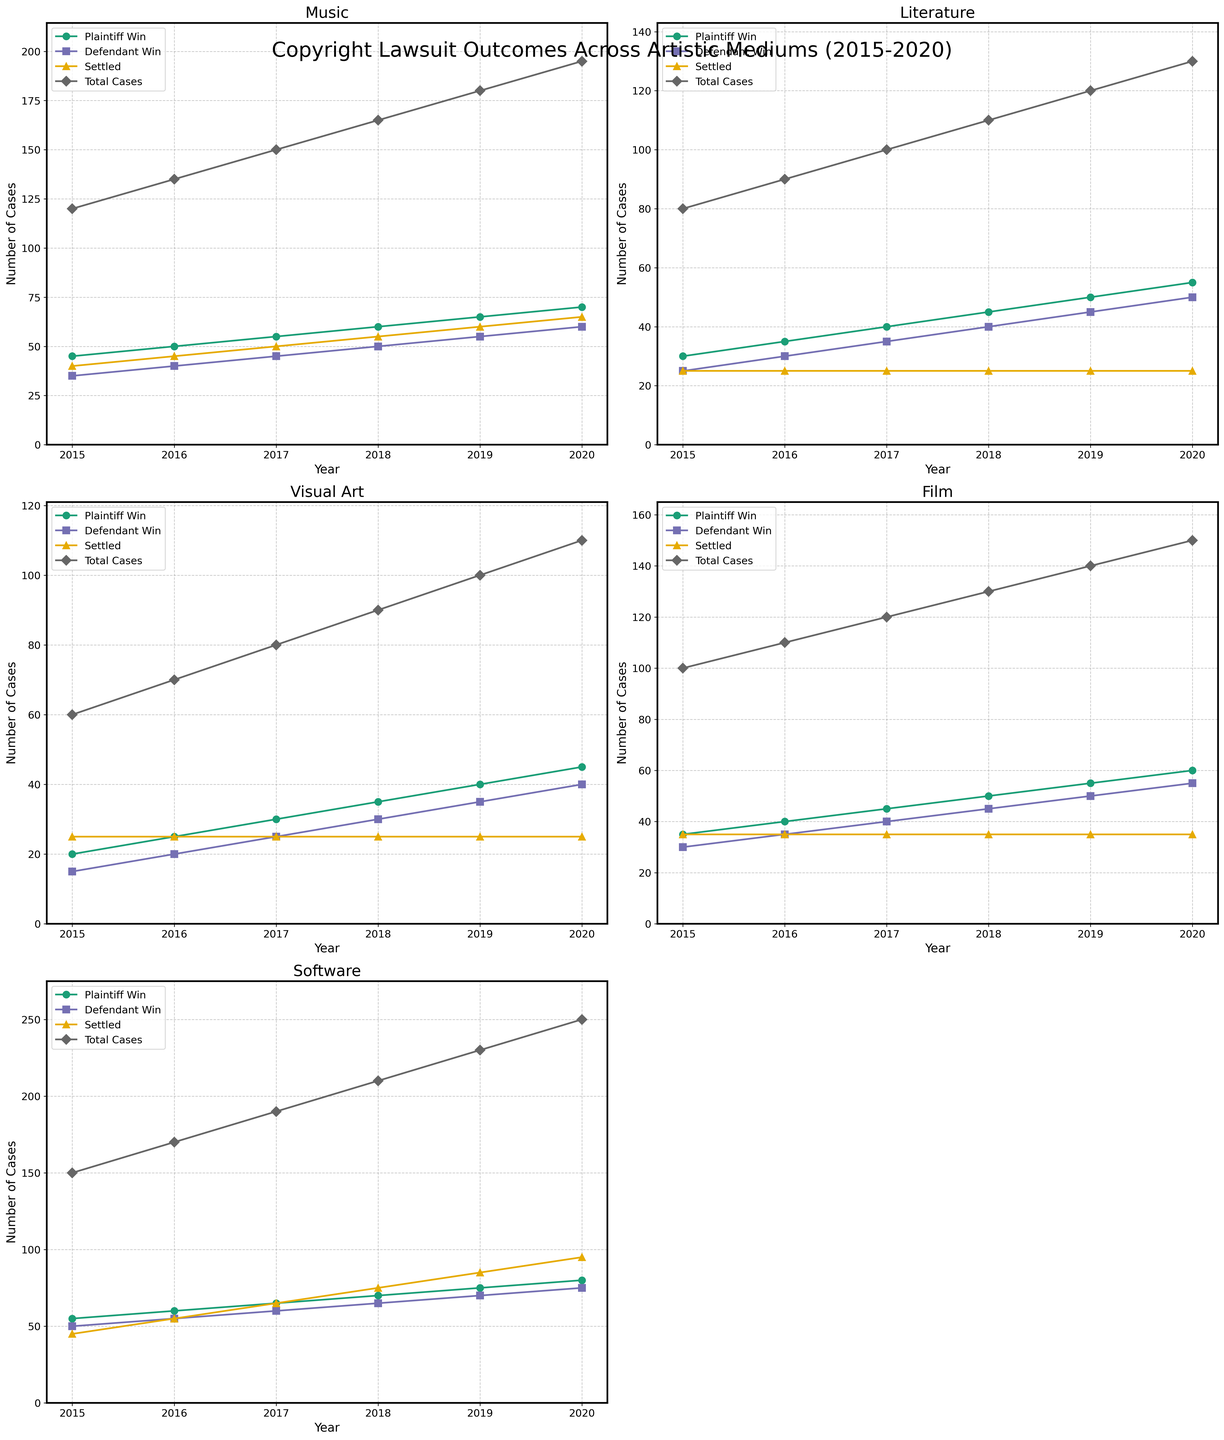What artistic medium showed the highest number of total cases in 2020? To find the answer, examine the "Total Cases" line for each subplot and check the year 2020. Compare the total cases for all mediums; Software has the highest number.
Answer: Software Which medium had the greatest increase in plaintiff wins from 2015 to 2020? Calculate the difference in plaintiff wins between 2015 and 2020 for each medium. The increases are: Music (70-45 = 25), Literature (55-30 = 25), Visual Art (45-20 = 25), Film (60-35 = 25), Software (80-55 = 25). All mediums show equal increases.
Answer: All mediums In 2018, which artistic medium had the highest number of settled cases? Examine the "Settled" line for each subplot and check the year 2018. Compare the settled cases for all mediums; Software has the highest settled cases (75).
Answer: Software Between 2015 and 2020, did the number of settled cases in Literature remain the same, increase, or decrease? Review the "Settled" line in the Literature subplot and see if it changes from 2015 (25) to 2020 (25). It remains the same.
Answer: Remain the same For the Music medium, what is the difference between total cases and settled cases in 2019? Look at the subplot for Music in the year 2019. The "Total Cases" value is 180 and "Settled" value is 60. The difference is 180 - 60 = 120.
Answer: 120 Which medium consistently had the lowest defendant wins from 2015 to 2020? Examine the "Defendant Win" lines across all subplots for each year. Visual Art has the lowest number of defendant wins consistently across the years.
Answer: Visual Art In 2016, how many more total cases were there for Film compared to Visual Art? From the Film subplot, the "Total Cases" in 2016 is 110. For Visual Art, it is 70. The difference is 110 - 70 = 40.
Answer: 40 Between 2015 and 2020, which medium showed the least overall growth in total cases? Examine the difference in "Total Cases" from 2015 to 2020 for each medium: Music (195-120=75), Literature (130-80=50), Visual Art (110-60=50), Film (150-100=50), Software (250-150=100). Visual Art, Literature, and Film showed the least growth of 50 cases.
Answer: Visual Art, Literature, Film What proportion of total cases were plaintiff wins in 2017 for Software? In 2017, Software had 190 total cases and 65 plaintiff wins. The proportion is 65/190 = 0.342 or 34.2%.
Answer: 34.2% Which medium had an equal number of plaintiff and defendant wins in any year? Review each subplot for any year where the "Plaintiff Win" and "Defendant Win" lines converge. There is no such occurrence in the data provided.
Answer: None 